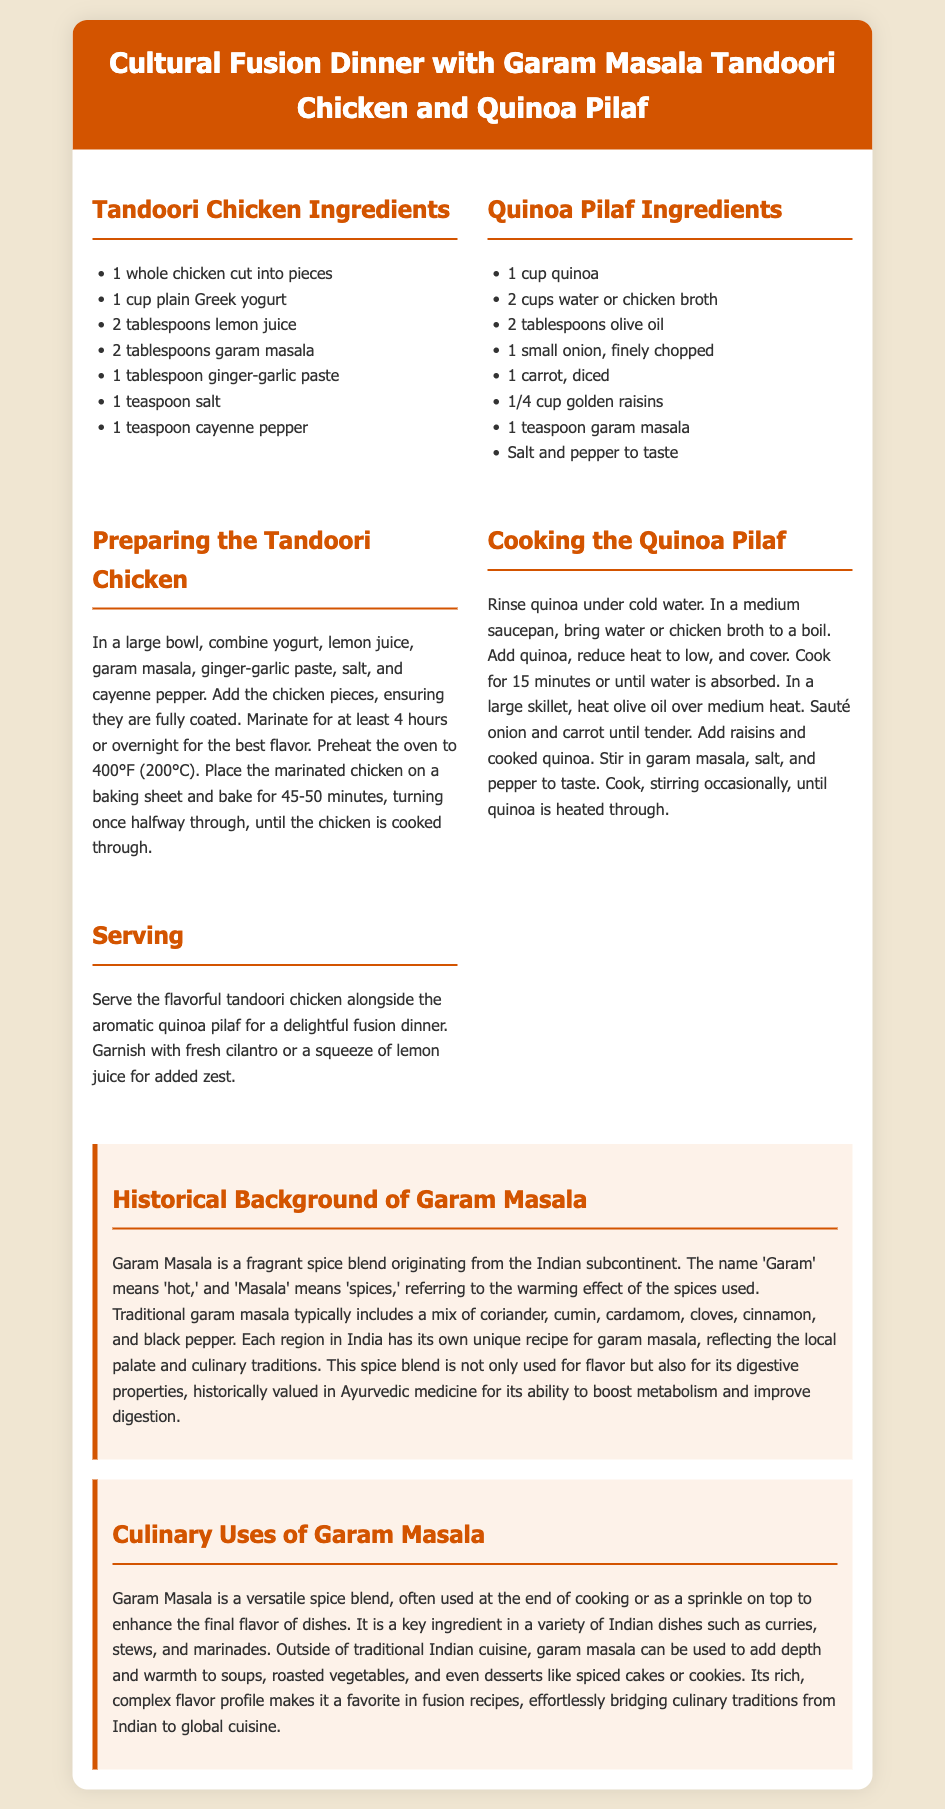What is the main dish in this recipe? The main dish is mentioned in the title of the recipe card, which describes it as Garam Masala Tandoori Chicken.
Answer: Garam Masala Tandoori Chicken How many hours should the chicken be marinated? The recipe specifies that the chicken should be marinated for at least 4 hours or overnight for the best flavor.
Answer: 4 hours What ingredient is used to enhance the pilaf's flavor? The recipe indicates that garam masala is incorporated into the quinoa pilaf for added flavor.
Answer: Garam masala What does 'Garam' mean in Garam Masala? The document notes that 'Garam' means 'hot' in the context of the spice blend's name.
Answer: Hot Which region traditionally uses garam masala? The historical background section states that garam masala originates from the Indian subcontinent.
Answer: Indian subcontinent What type of vinegar is mentioned for the chicken marinade? The marinade recipe mentions lemon juice as one of the key ingredients for flavor.
Answer: Lemon juice How long does the chicken need to bake? The baking instruction specifies that the chicken should bake for 45-50 minutes.
Answer: 45-50 minutes What culinary property has garam masala historically been valued for? The historical background indicates that garam masala has been valued in Ayurvedic medicine for its digestive properties.
Answer: Digestive properties What vegetable is included in the quinoa pilaf? The ingredients for the quinoa pilaf list diced carrot as one of the components.
Answer: Carrot 